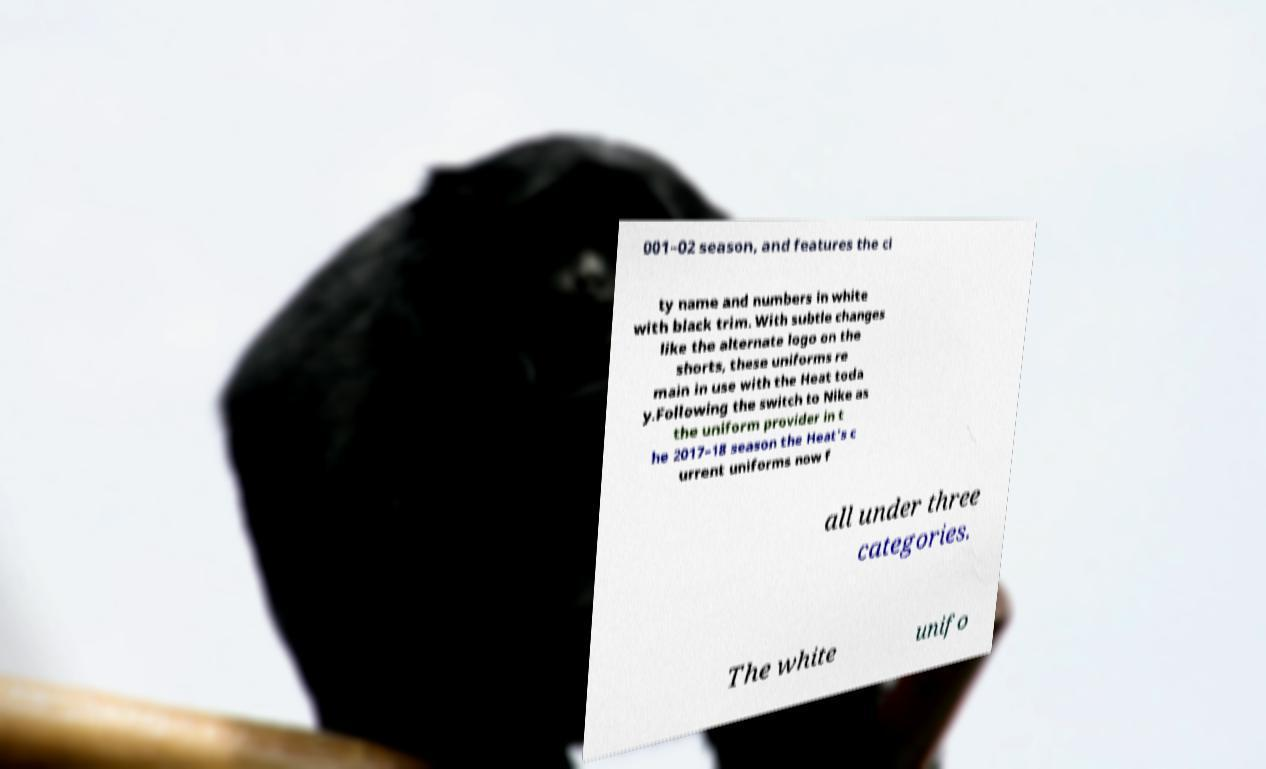I need the written content from this picture converted into text. Can you do that? 001–02 season, and features the ci ty name and numbers in white with black trim. With subtle changes like the alternate logo on the shorts, these uniforms re main in use with the Heat toda y.Following the switch to Nike as the uniform provider in t he 2017–18 season the Heat's c urrent uniforms now f all under three categories. The white unifo 